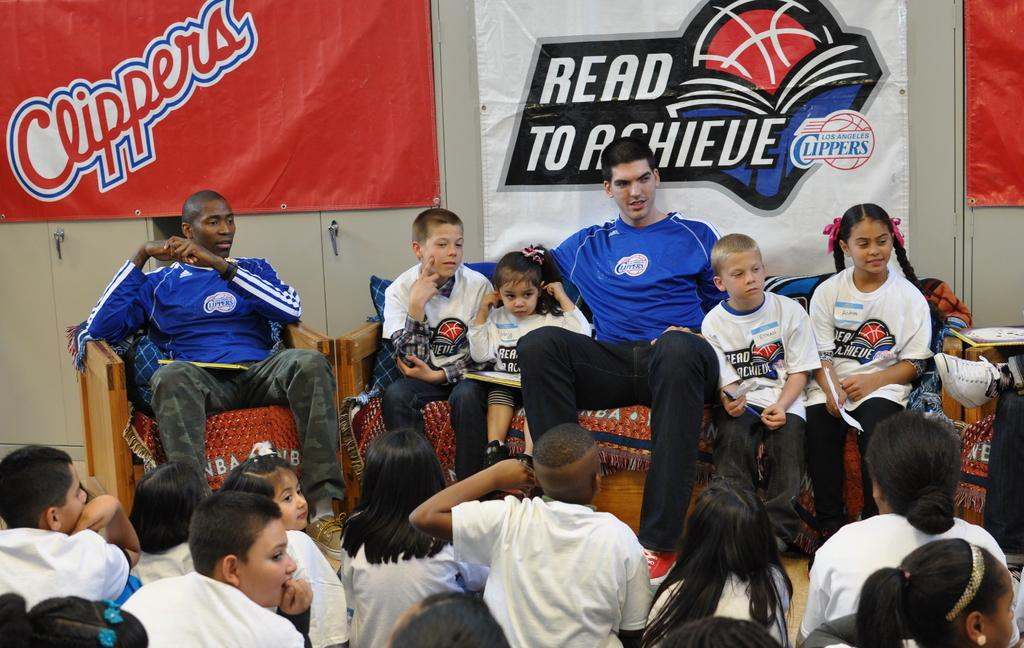<image>
Summarize the visual content of the image. The basketball players from the Clippers are talking to kids. 